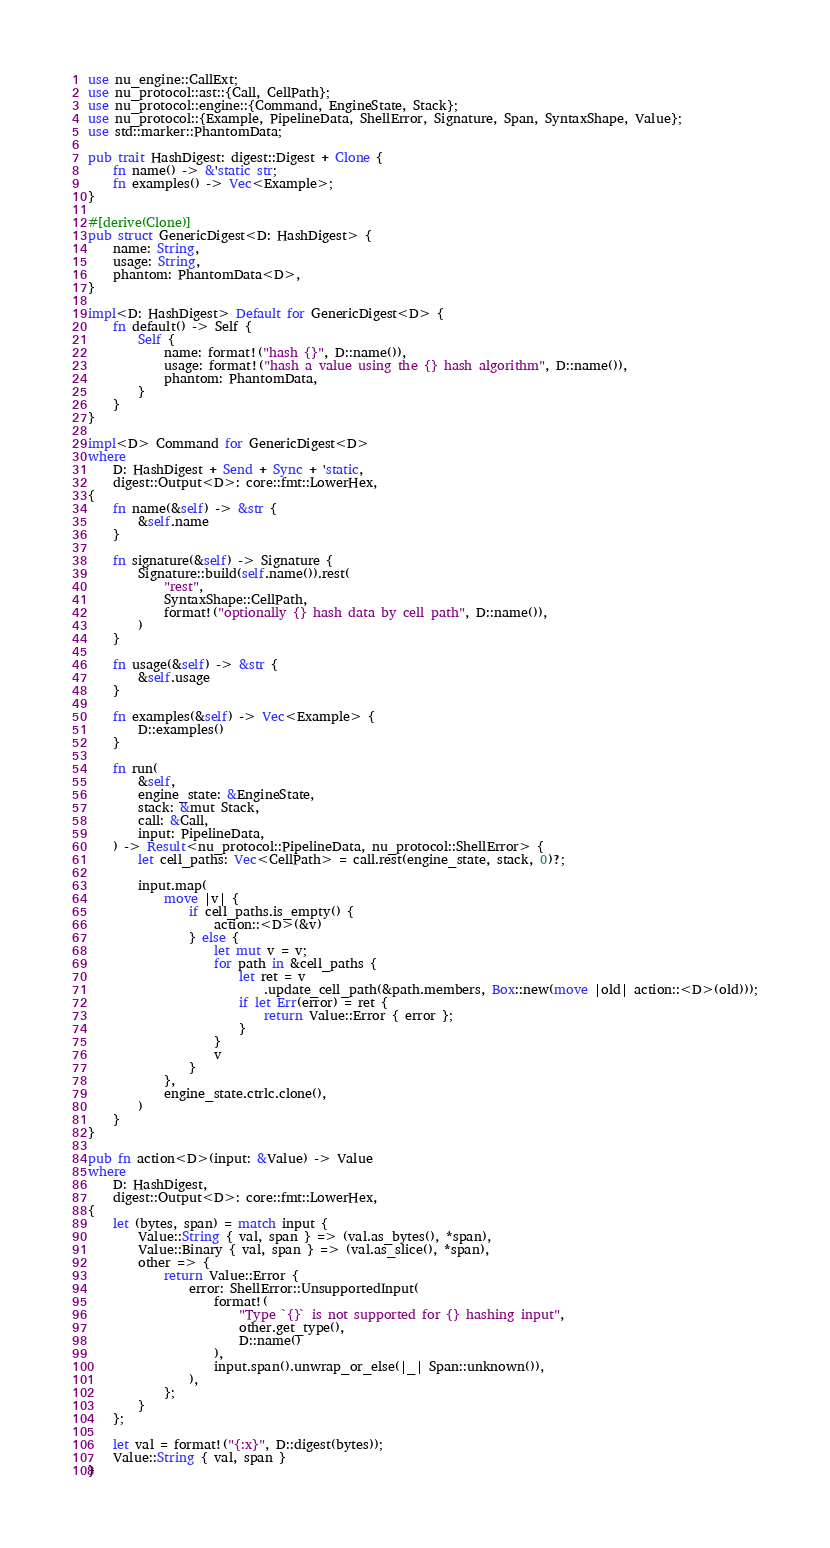Convert code to text. <code><loc_0><loc_0><loc_500><loc_500><_Rust_>use nu_engine::CallExt;
use nu_protocol::ast::{Call, CellPath};
use nu_protocol::engine::{Command, EngineState, Stack};
use nu_protocol::{Example, PipelineData, ShellError, Signature, Span, SyntaxShape, Value};
use std::marker::PhantomData;

pub trait HashDigest: digest::Digest + Clone {
    fn name() -> &'static str;
    fn examples() -> Vec<Example>;
}

#[derive(Clone)]
pub struct GenericDigest<D: HashDigest> {
    name: String,
    usage: String,
    phantom: PhantomData<D>,
}

impl<D: HashDigest> Default for GenericDigest<D> {
    fn default() -> Self {
        Self {
            name: format!("hash {}", D::name()),
            usage: format!("hash a value using the {} hash algorithm", D::name()),
            phantom: PhantomData,
        }
    }
}

impl<D> Command for GenericDigest<D>
where
    D: HashDigest + Send + Sync + 'static,
    digest::Output<D>: core::fmt::LowerHex,
{
    fn name(&self) -> &str {
        &self.name
    }

    fn signature(&self) -> Signature {
        Signature::build(self.name()).rest(
            "rest",
            SyntaxShape::CellPath,
            format!("optionally {} hash data by cell path", D::name()),
        )
    }

    fn usage(&self) -> &str {
        &self.usage
    }

    fn examples(&self) -> Vec<Example> {
        D::examples()
    }

    fn run(
        &self,
        engine_state: &EngineState,
        stack: &mut Stack,
        call: &Call,
        input: PipelineData,
    ) -> Result<nu_protocol::PipelineData, nu_protocol::ShellError> {
        let cell_paths: Vec<CellPath> = call.rest(engine_state, stack, 0)?;

        input.map(
            move |v| {
                if cell_paths.is_empty() {
                    action::<D>(&v)
                } else {
                    let mut v = v;
                    for path in &cell_paths {
                        let ret = v
                            .update_cell_path(&path.members, Box::new(move |old| action::<D>(old)));
                        if let Err(error) = ret {
                            return Value::Error { error };
                        }
                    }
                    v
                }
            },
            engine_state.ctrlc.clone(),
        )
    }
}

pub fn action<D>(input: &Value) -> Value
where
    D: HashDigest,
    digest::Output<D>: core::fmt::LowerHex,
{
    let (bytes, span) = match input {
        Value::String { val, span } => (val.as_bytes(), *span),
        Value::Binary { val, span } => (val.as_slice(), *span),
        other => {
            return Value::Error {
                error: ShellError::UnsupportedInput(
                    format!(
                        "Type `{}` is not supported for {} hashing input",
                        other.get_type(),
                        D::name()
                    ),
                    input.span().unwrap_or_else(|_| Span::unknown()),
                ),
            };
        }
    };

    let val = format!("{:x}", D::digest(bytes));
    Value::String { val, span }
}
</code> 